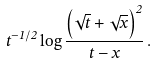<formula> <loc_0><loc_0><loc_500><loc_500>t ^ { - 1 / 2 } \log { \frac { \left ( \sqrt { t } + \sqrt { x } \right ) ^ { 2 } } { t - x } } \, .</formula> 